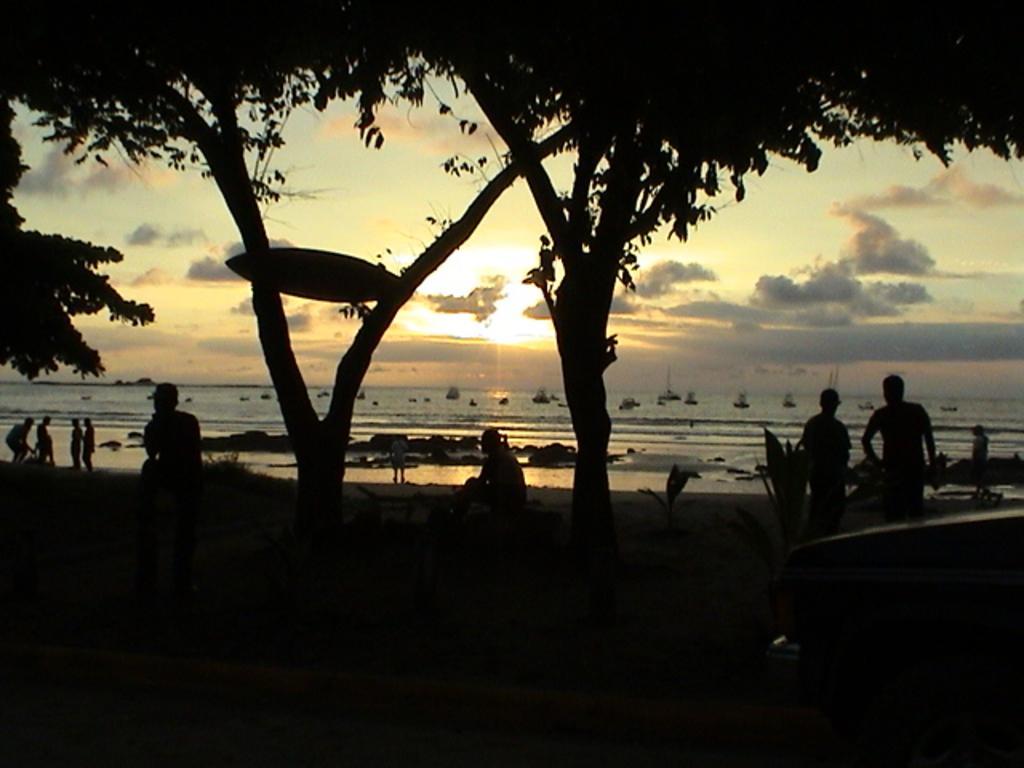Can you describe this image briefly? This image is taken outdoors. In the background there is the sky with clouds and sun and there is a sea with waves. There are a few boats on the sea. In the middle of the image there are a few trees and a few people are standing on the ground and a few are sitting. 